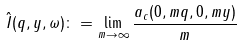Convert formula to latex. <formula><loc_0><loc_0><loc_500><loc_500>\hat { I } ( q , y , \omega ) \colon = \lim _ { m \to \infty } \frac { a _ { c } ( 0 , m q , 0 , m y ) } { m }</formula> 